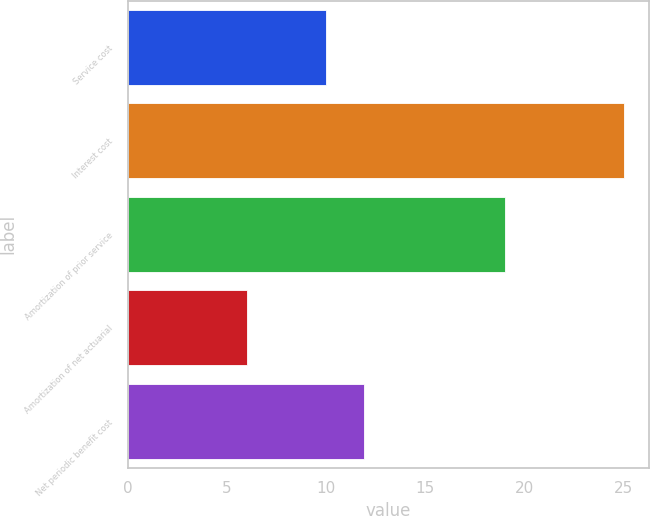<chart> <loc_0><loc_0><loc_500><loc_500><bar_chart><fcel>Service cost<fcel>Interest cost<fcel>Amortization of prior service<fcel>Amortization of net actuarial<fcel>Net periodic benefit cost<nl><fcel>10<fcel>25<fcel>19<fcel>6<fcel>11.9<nl></chart> 